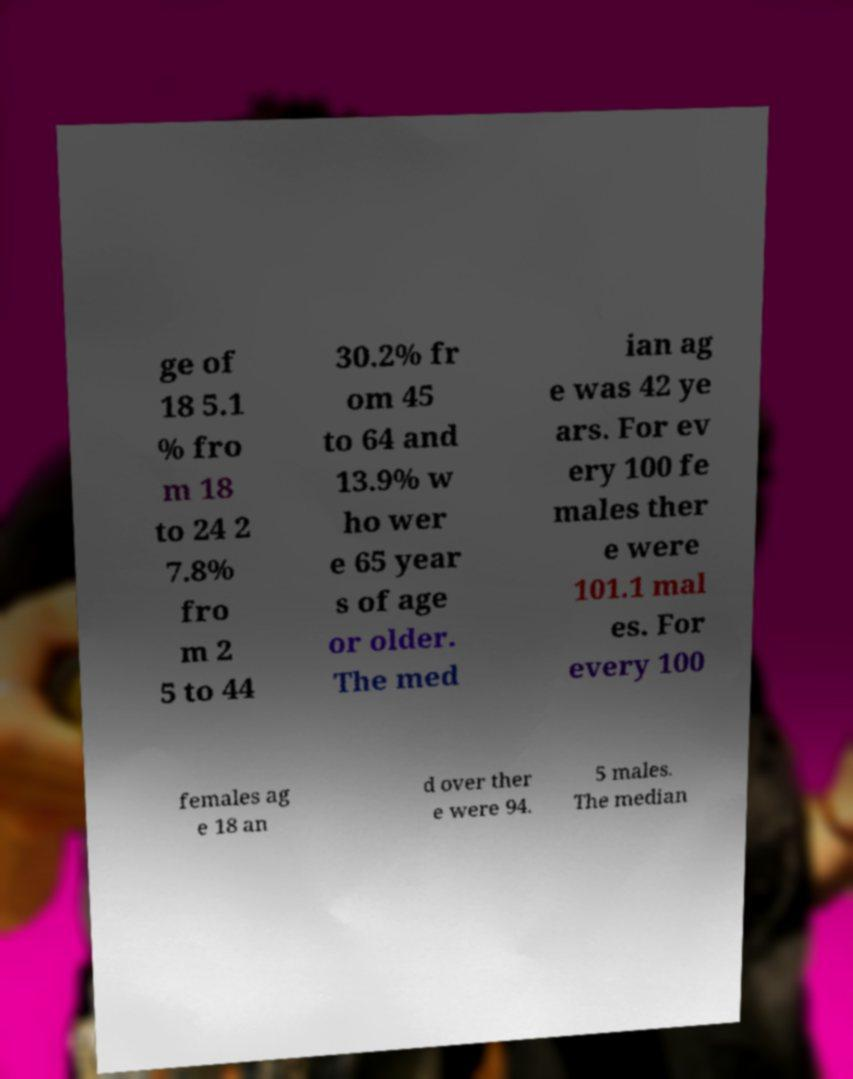Can you read and provide the text displayed in the image?This photo seems to have some interesting text. Can you extract and type it out for me? ge of 18 5.1 % fro m 18 to 24 2 7.8% fro m 2 5 to 44 30.2% fr om 45 to 64 and 13.9% w ho wer e 65 year s of age or older. The med ian ag e was 42 ye ars. For ev ery 100 fe males ther e were 101.1 mal es. For every 100 females ag e 18 an d over ther e were 94. 5 males. The median 